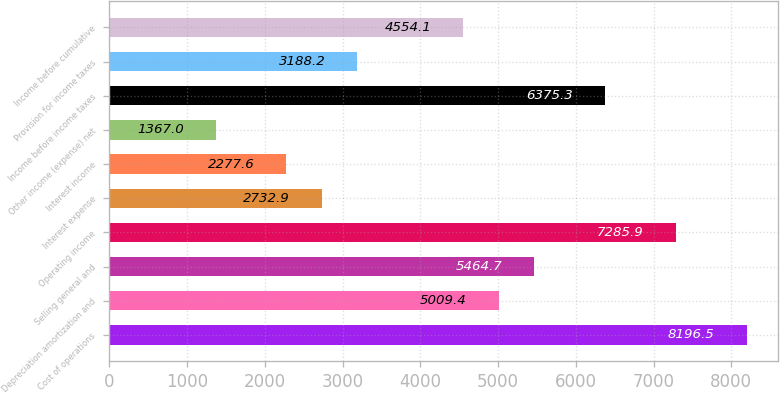<chart> <loc_0><loc_0><loc_500><loc_500><bar_chart><fcel>Cost of operations<fcel>Depreciation amortization and<fcel>Selling general and<fcel>Operating income<fcel>Interest expense<fcel>Interest income<fcel>Other income (expense) net<fcel>Income before income taxes<fcel>Provision for income taxes<fcel>Income before cumulative<nl><fcel>8196.5<fcel>5009.4<fcel>5464.7<fcel>7285.9<fcel>2732.9<fcel>2277.6<fcel>1367<fcel>6375.3<fcel>3188.2<fcel>4554.1<nl></chart> 